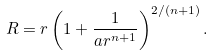<formula> <loc_0><loc_0><loc_500><loc_500>R = r \left ( 1 + \frac { 1 } { a r ^ { n + 1 } } \right ) ^ { 2 / ( n + 1 ) } .</formula> 